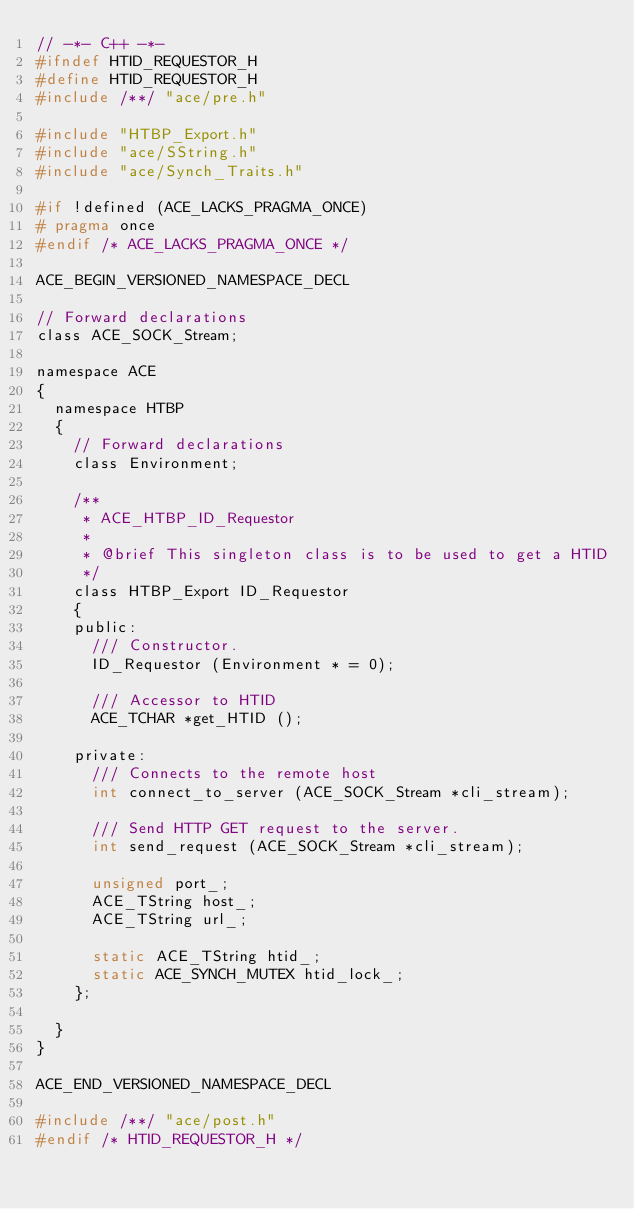<code> <loc_0><loc_0><loc_500><loc_500><_C_>// -*- C++ -*-
#ifndef HTID_REQUESTOR_H
#define HTID_REQUESTOR_H
#include /**/ "ace/pre.h"

#include "HTBP_Export.h"
#include "ace/SString.h"
#include "ace/Synch_Traits.h"

#if !defined (ACE_LACKS_PRAGMA_ONCE)
# pragma once
#endif /* ACE_LACKS_PRAGMA_ONCE */

ACE_BEGIN_VERSIONED_NAMESPACE_DECL

// Forward declarations
class ACE_SOCK_Stream;

namespace ACE
{
  namespace HTBP
  {
    // Forward declarations
    class Environment;

    /**
     * ACE_HTBP_ID_Requestor
     *
     * @brief This singleton class is to be used to get a HTID
     */
    class HTBP_Export ID_Requestor
    {
    public:
      /// Constructor.
      ID_Requestor (Environment * = 0);

      /// Accessor to HTID
      ACE_TCHAR *get_HTID ();

    private:
      /// Connects to the remote host
      int connect_to_server (ACE_SOCK_Stream *cli_stream);

      /// Send HTTP GET request to the server.
      int send_request (ACE_SOCK_Stream *cli_stream);

      unsigned port_;
      ACE_TString host_;
      ACE_TString url_;

      static ACE_TString htid_;
      static ACE_SYNCH_MUTEX htid_lock_;
    };

  }
}

ACE_END_VERSIONED_NAMESPACE_DECL

#include /**/ "ace/post.h"
#endif /* HTID_REQUESTOR_H */
</code> 